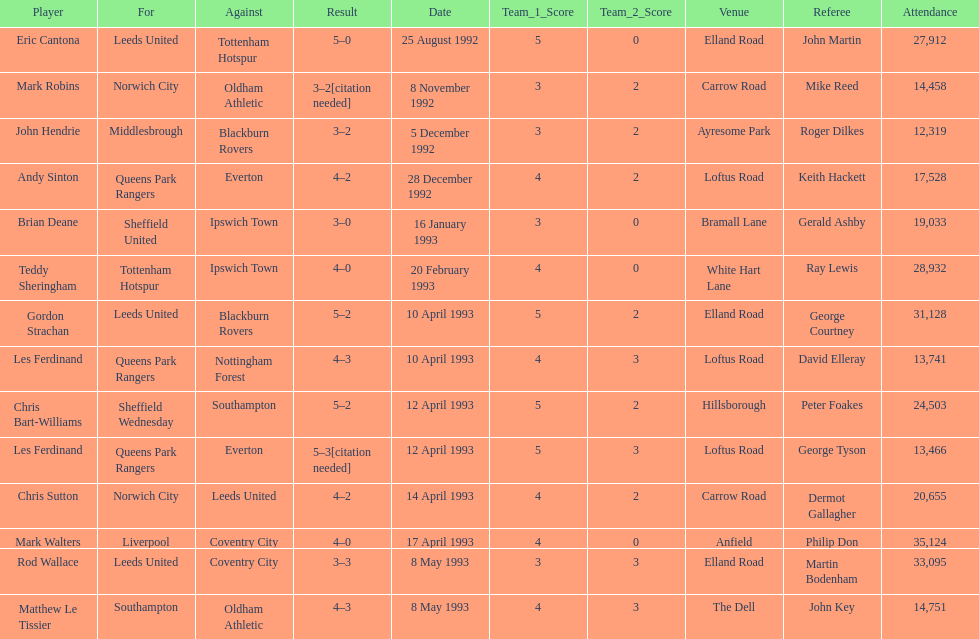Name the only player from france. Eric Cantona. 